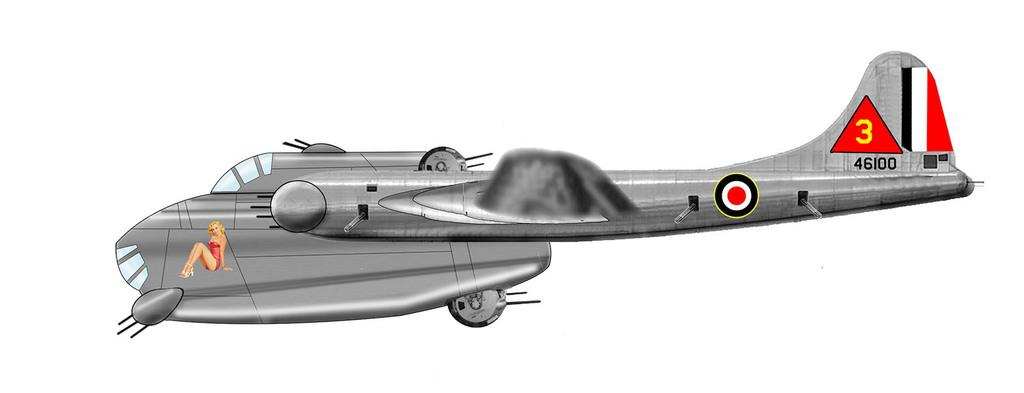<image>
Provide a brief description of the given image. Sketch of a plane with the numbers 46100 near the tail. 